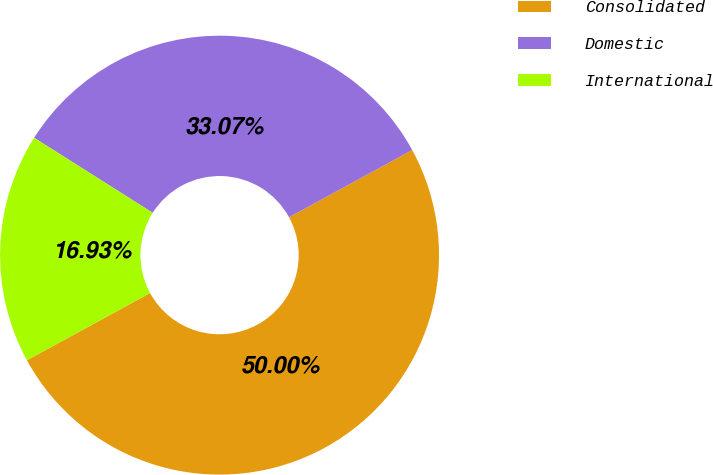Convert chart. <chart><loc_0><loc_0><loc_500><loc_500><pie_chart><fcel>Consolidated<fcel>Domestic<fcel>International<nl><fcel>50.0%<fcel>33.07%<fcel>16.93%<nl></chart> 